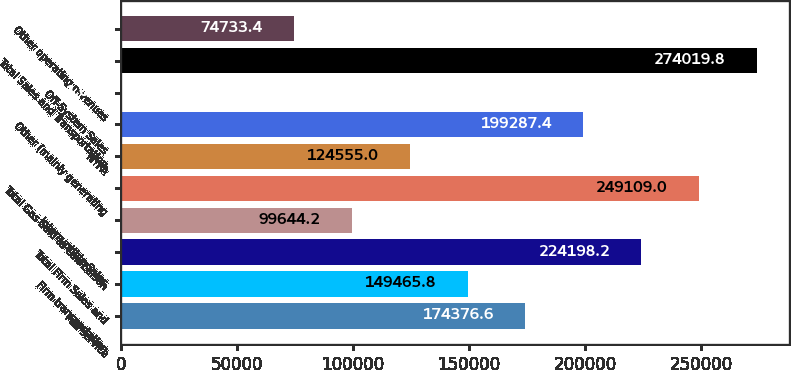Convert chart to OTSL. <chart><loc_0><loc_0><loc_500><loc_500><bar_chart><fcel>Full service<fcel>Firm transportation<fcel>Total Firm Sales and<fcel>Interruptible Sales<fcel>Total Gas Sold to Con Edison<fcel>NYPA<fcel>Other (mainly generating<fcel>Off-System Sales<fcel>Total Sales and Transportation<fcel>Other operating revenues<nl><fcel>174377<fcel>149466<fcel>224198<fcel>99644.2<fcel>249109<fcel>124555<fcel>199287<fcel>1<fcel>274020<fcel>74733.4<nl></chart> 